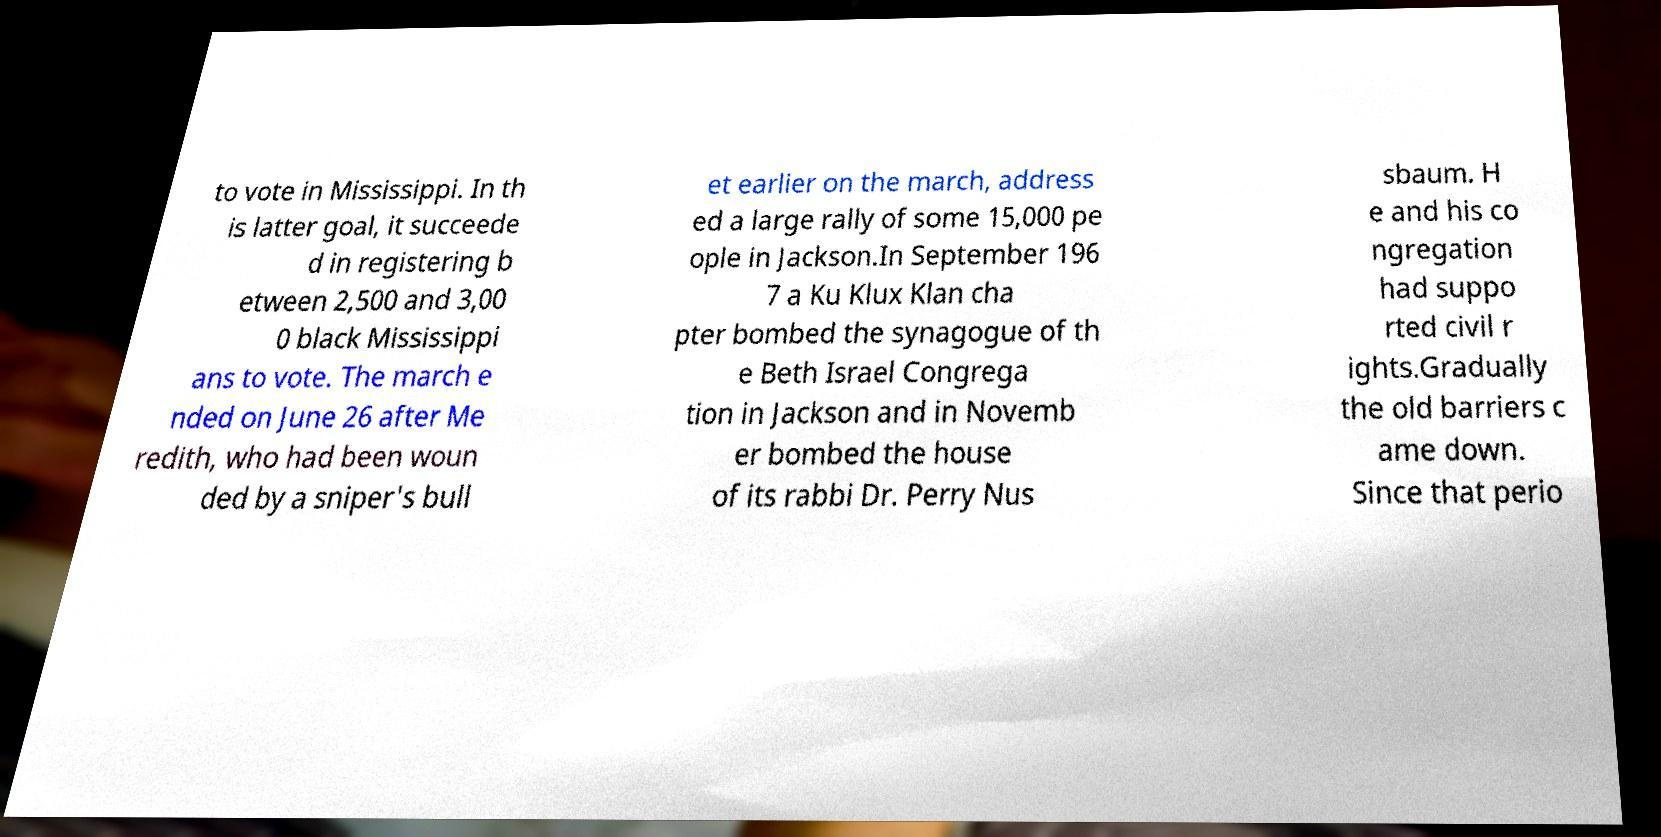Can you read and provide the text displayed in the image?This photo seems to have some interesting text. Can you extract and type it out for me? to vote in Mississippi. In th is latter goal, it succeede d in registering b etween 2,500 and 3,00 0 black Mississippi ans to vote. The march e nded on June 26 after Me redith, who had been woun ded by a sniper's bull et earlier on the march, address ed a large rally of some 15,000 pe ople in Jackson.In September 196 7 a Ku Klux Klan cha pter bombed the synagogue of th e Beth Israel Congrega tion in Jackson and in Novemb er bombed the house of its rabbi Dr. Perry Nus sbaum. H e and his co ngregation had suppo rted civil r ights.Gradually the old barriers c ame down. Since that perio 